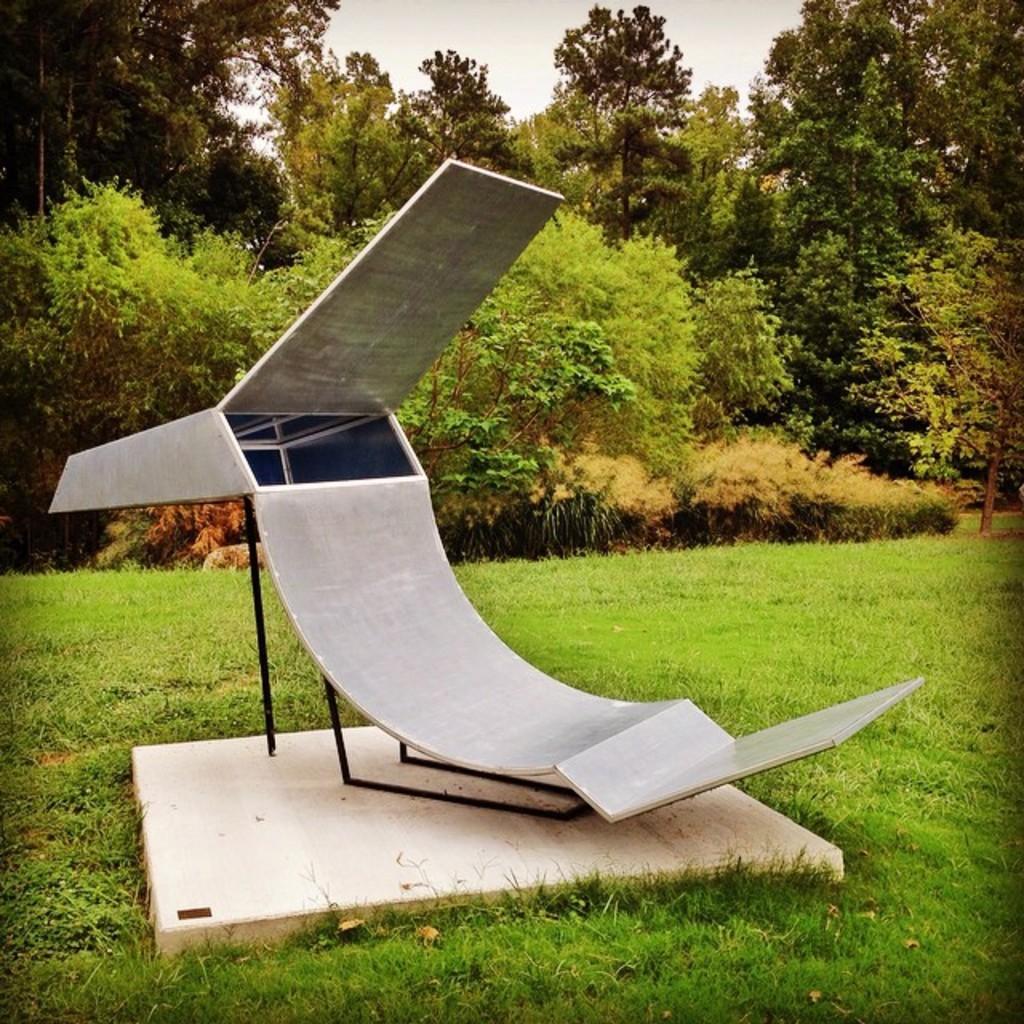How would you summarize this image in a sentence or two? In this image there is a slide on the stone and the stone is in the grass, there are few trees and the sky. 